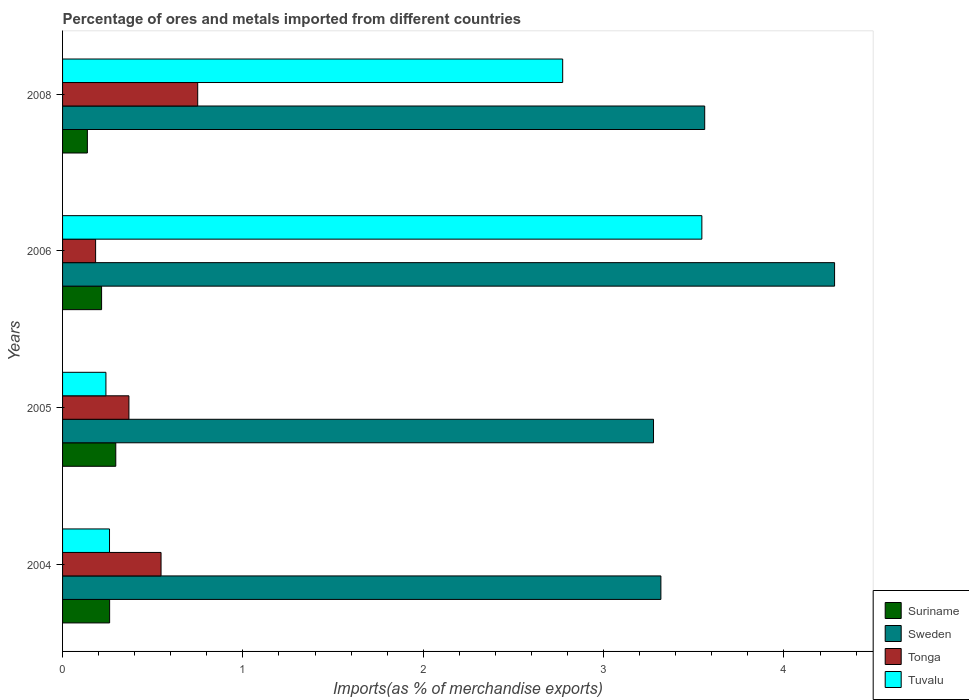How many different coloured bars are there?
Your response must be concise. 4. How many groups of bars are there?
Your response must be concise. 4. How many bars are there on the 3rd tick from the top?
Your response must be concise. 4. What is the percentage of imports to different countries in Suriname in 2008?
Your answer should be very brief. 0.14. Across all years, what is the maximum percentage of imports to different countries in Tonga?
Provide a succinct answer. 0.75. Across all years, what is the minimum percentage of imports to different countries in Tuvalu?
Ensure brevity in your answer.  0.24. In which year was the percentage of imports to different countries in Sweden minimum?
Your answer should be compact. 2005. What is the total percentage of imports to different countries in Sweden in the graph?
Keep it short and to the point. 14.44. What is the difference between the percentage of imports to different countries in Sweden in 2004 and that in 2006?
Make the answer very short. -0.96. What is the difference between the percentage of imports to different countries in Tuvalu in 2006 and the percentage of imports to different countries in Sweden in 2005?
Your answer should be very brief. 0.27. What is the average percentage of imports to different countries in Sweden per year?
Your answer should be compact. 3.61. In the year 2006, what is the difference between the percentage of imports to different countries in Tonga and percentage of imports to different countries in Suriname?
Keep it short and to the point. -0.03. What is the ratio of the percentage of imports to different countries in Tuvalu in 2004 to that in 2006?
Your answer should be compact. 0.07. Is the percentage of imports to different countries in Tonga in 2006 less than that in 2008?
Your answer should be compact. Yes. What is the difference between the highest and the second highest percentage of imports to different countries in Tonga?
Your answer should be compact. 0.2. What is the difference between the highest and the lowest percentage of imports to different countries in Sweden?
Your response must be concise. 1. Is it the case that in every year, the sum of the percentage of imports to different countries in Suriname and percentage of imports to different countries in Sweden is greater than the sum of percentage of imports to different countries in Tuvalu and percentage of imports to different countries in Tonga?
Your answer should be very brief. Yes. What does the 2nd bar from the top in 2006 represents?
Your answer should be compact. Tonga. What does the 3rd bar from the bottom in 2006 represents?
Your answer should be very brief. Tonga. How many bars are there?
Provide a succinct answer. 16. Are all the bars in the graph horizontal?
Offer a very short reply. Yes. How many years are there in the graph?
Your response must be concise. 4. What is the difference between two consecutive major ticks on the X-axis?
Keep it short and to the point. 1. Are the values on the major ticks of X-axis written in scientific E-notation?
Provide a succinct answer. No. Does the graph contain grids?
Offer a terse response. No. Where does the legend appear in the graph?
Offer a terse response. Bottom right. How are the legend labels stacked?
Offer a terse response. Vertical. What is the title of the graph?
Keep it short and to the point. Percentage of ores and metals imported from different countries. Does "Papua New Guinea" appear as one of the legend labels in the graph?
Ensure brevity in your answer.  No. What is the label or title of the X-axis?
Your response must be concise. Imports(as % of merchandise exports). What is the Imports(as % of merchandise exports) of Suriname in 2004?
Your response must be concise. 0.26. What is the Imports(as % of merchandise exports) of Sweden in 2004?
Give a very brief answer. 3.32. What is the Imports(as % of merchandise exports) in Tonga in 2004?
Ensure brevity in your answer.  0.55. What is the Imports(as % of merchandise exports) in Tuvalu in 2004?
Provide a short and direct response. 0.26. What is the Imports(as % of merchandise exports) of Suriname in 2005?
Keep it short and to the point. 0.3. What is the Imports(as % of merchandise exports) of Sweden in 2005?
Your answer should be compact. 3.28. What is the Imports(as % of merchandise exports) in Tonga in 2005?
Provide a succinct answer. 0.37. What is the Imports(as % of merchandise exports) of Tuvalu in 2005?
Keep it short and to the point. 0.24. What is the Imports(as % of merchandise exports) of Suriname in 2006?
Give a very brief answer. 0.22. What is the Imports(as % of merchandise exports) in Sweden in 2006?
Offer a very short reply. 4.28. What is the Imports(as % of merchandise exports) in Tonga in 2006?
Keep it short and to the point. 0.18. What is the Imports(as % of merchandise exports) in Tuvalu in 2006?
Make the answer very short. 3.54. What is the Imports(as % of merchandise exports) in Suriname in 2008?
Make the answer very short. 0.14. What is the Imports(as % of merchandise exports) in Sweden in 2008?
Offer a terse response. 3.56. What is the Imports(as % of merchandise exports) in Tonga in 2008?
Make the answer very short. 0.75. What is the Imports(as % of merchandise exports) in Tuvalu in 2008?
Provide a succinct answer. 2.77. Across all years, what is the maximum Imports(as % of merchandise exports) in Suriname?
Provide a short and direct response. 0.3. Across all years, what is the maximum Imports(as % of merchandise exports) of Sweden?
Make the answer very short. 4.28. Across all years, what is the maximum Imports(as % of merchandise exports) in Tonga?
Offer a terse response. 0.75. Across all years, what is the maximum Imports(as % of merchandise exports) of Tuvalu?
Offer a terse response. 3.54. Across all years, what is the minimum Imports(as % of merchandise exports) in Suriname?
Your answer should be very brief. 0.14. Across all years, what is the minimum Imports(as % of merchandise exports) of Sweden?
Give a very brief answer. 3.28. Across all years, what is the minimum Imports(as % of merchandise exports) in Tonga?
Give a very brief answer. 0.18. Across all years, what is the minimum Imports(as % of merchandise exports) in Tuvalu?
Make the answer very short. 0.24. What is the total Imports(as % of merchandise exports) in Suriname in the graph?
Keep it short and to the point. 0.91. What is the total Imports(as % of merchandise exports) in Sweden in the graph?
Give a very brief answer. 14.44. What is the total Imports(as % of merchandise exports) in Tonga in the graph?
Ensure brevity in your answer.  1.85. What is the total Imports(as % of merchandise exports) of Tuvalu in the graph?
Offer a very short reply. 6.82. What is the difference between the Imports(as % of merchandise exports) in Suriname in 2004 and that in 2005?
Keep it short and to the point. -0.03. What is the difference between the Imports(as % of merchandise exports) in Sweden in 2004 and that in 2005?
Provide a succinct answer. 0.04. What is the difference between the Imports(as % of merchandise exports) in Tonga in 2004 and that in 2005?
Provide a succinct answer. 0.18. What is the difference between the Imports(as % of merchandise exports) of Tuvalu in 2004 and that in 2005?
Ensure brevity in your answer.  0.02. What is the difference between the Imports(as % of merchandise exports) in Suriname in 2004 and that in 2006?
Provide a succinct answer. 0.04. What is the difference between the Imports(as % of merchandise exports) in Sweden in 2004 and that in 2006?
Your answer should be compact. -0.96. What is the difference between the Imports(as % of merchandise exports) in Tonga in 2004 and that in 2006?
Provide a succinct answer. 0.36. What is the difference between the Imports(as % of merchandise exports) in Tuvalu in 2004 and that in 2006?
Your answer should be compact. -3.28. What is the difference between the Imports(as % of merchandise exports) in Suriname in 2004 and that in 2008?
Keep it short and to the point. 0.12. What is the difference between the Imports(as % of merchandise exports) in Sweden in 2004 and that in 2008?
Give a very brief answer. -0.24. What is the difference between the Imports(as % of merchandise exports) in Tonga in 2004 and that in 2008?
Give a very brief answer. -0.2. What is the difference between the Imports(as % of merchandise exports) of Tuvalu in 2004 and that in 2008?
Your answer should be compact. -2.51. What is the difference between the Imports(as % of merchandise exports) in Suriname in 2005 and that in 2006?
Provide a succinct answer. 0.08. What is the difference between the Imports(as % of merchandise exports) in Sweden in 2005 and that in 2006?
Provide a succinct answer. -1. What is the difference between the Imports(as % of merchandise exports) of Tonga in 2005 and that in 2006?
Offer a terse response. 0.18. What is the difference between the Imports(as % of merchandise exports) in Tuvalu in 2005 and that in 2006?
Offer a terse response. -3.3. What is the difference between the Imports(as % of merchandise exports) of Suriname in 2005 and that in 2008?
Provide a succinct answer. 0.16. What is the difference between the Imports(as % of merchandise exports) in Sweden in 2005 and that in 2008?
Give a very brief answer. -0.28. What is the difference between the Imports(as % of merchandise exports) in Tonga in 2005 and that in 2008?
Ensure brevity in your answer.  -0.38. What is the difference between the Imports(as % of merchandise exports) in Tuvalu in 2005 and that in 2008?
Ensure brevity in your answer.  -2.53. What is the difference between the Imports(as % of merchandise exports) of Suriname in 2006 and that in 2008?
Your answer should be compact. 0.08. What is the difference between the Imports(as % of merchandise exports) of Sweden in 2006 and that in 2008?
Provide a short and direct response. 0.72. What is the difference between the Imports(as % of merchandise exports) in Tonga in 2006 and that in 2008?
Your answer should be compact. -0.57. What is the difference between the Imports(as % of merchandise exports) in Tuvalu in 2006 and that in 2008?
Offer a very short reply. 0.77. What is the difference between the Imports(as % of merchandise exports) in Suriname in 2004 and the Imports(as % of merchandise exports) in Sweden in 2005?
Provide a short and direct response. -3.02. What is the difference between the Imports(as % of merchandise exports) in Suriname in 2004 and the Imports(as % of merchandise exports) in Tonga in 2005?
Ensure brevity in your answer.  -0.11. What is the difference between the Imports(as % of merchandise exports) in Suriname in 2004 and the Imports(as % of merchandise exports) in Tuvalu in 2005?
Your response must be concise. 0.02. What is the difference between the Imports(as % of merchandise exports) of Sweden in 2004 and the Imports(as % of merchandise exports) of Tonga in 2005?
Offer a very short reply. 2.95. What is the difference between the Imports(as % of merchandise exports) in Sweden in 2004 and the Imports(as % of merchandise exports) in Tuvalu in 2005?
Your answer should be compact. 3.08. What is the difference between the Imports(as % of merchandise exports) in Tonga in 2004 and the Imports(as % of merchandise exports) in Tuvalu in 2005?
Offer a terse response. 0.31. What is the difference between the Imports(as % of merchandise exports) in Suriname in 2004 and the Imports(as % of merchandise exports) in Sweden in 2006?
Ensure brevity in your answer.  -4.02. What is the difference between the Imports(as % of merchandise exports) of Suriname in 2004 and the Imports(as % of merchandise exports) of Tonga in 2006?
Provide a short and direct response. 0.08. What is the difference between the Imports(as % of merchandise exports) of Suriname in 2004 and the Imports(as % of merchandise exports) of Tuvalu in 2006?
Your answer should be very brief. -3.28. What is the difference between the Imports(as % of merchandise exports) in Sweden in 2004 and the Imports(as % of merchandise exports) in Tonga in 2006?
Ensure brevity in your answer.  3.13. What is the difference between the Imports(as % of merchandise exports) in Sweden in 2004 and the Imports(as % of merchandise exports) in Tuvalu in 2006?
Your answer should be very brief. -0.23. What is the difference between the Imports(as % of merchandise exports) in Tonga in 2004 and the Imports(as % of merchandise exports) in Tuvalu in 2006?
Your answer should be compact. -3. What is the difference between the Imports(as % of merchandise exports) of Suriname in 2004 and the Imports(as % of merchandise exports) of Sweden in 2008?
Make the answer very short. -3.3. What is the difference between the Imports(as % of merchandise exports) of Suriname in 2004 and the Imports(as % of merchandise exports) of Tonga in 2008?
Your answer should be very brief. -0.49. What is the difference between the Imports(as % of merchandise exports) of Suriname in 2004 and the Imports(as % of merchandise exports) of Tuvalu in 2008?
Ensure brevity in your answer.  -2.51. What is the difference between the Imports(as % of merchandise exports) of Sweden in 2004 and the Imports(as % of merchandise exports) of Tonga in 2008?
Keep it short and to the point. 2.57. What is the difference between the Imports(as % of merchandise exports) of Sweden in 2004 and the Imports(as % of merchandise exports) of Tuvalu in 2008?
Offer a very short reply. 0.54. What is the difference between the Imports(as % of merchandise exports) of Tonga in 2004 and the Imports(as % of merchandise exports) of Tuvalu in 2008?
Your answer should be very brief. -2.23. What is the difference between the Imports(as % of merchandise exports) in Suriname in 2005 and the Imports(as % of merchandise exports) in Sweden in 2006?
Provide a short and direct response. -3.99. What is the difference between the Imports(as % of merchandise exports) in Suriname in 2005 and the Imports(as % of merchandise exports) in Tonga in 2006?
Your answer should be compact. 0.11. What is the difference between the Imports(as % of merchandise exports) of Suriname in 2005 and the Imports(as % of merchandise exports) of Tuvalu in 2006?
Provide a short and direct response. -3.25. What is the difference between the Imports(as % of merchandise exports) of Sweden in 2005 and the Imports(as % of merchandise exports) of Tonga in 2006?
Your response must be concise. 3.09. What is the difference between the Imports(as % of merchandise exports) in Sweden in 2005 and the Imports(as % of merchandise exports) in Tuvalu in 2006?
Make the answer very short. -0.27. What is the difference between the Imports(as % of merchandise exports) in Tonga in 2005 and the Imports(as % of merchandise exports) in Tuvalu in 2006?
Provide a succinct answer. -3.18. What is the difference between the Imports(as % of merchandise exports) of Suriname in 2005 and the Imports(as % of merchandise exports) of Sweden in 2008?
Your answer should be very brief. -3.27. What is the difference between the Imports(as % of merchandise exports) in Suriname in 2005 and the Imports(as % of merchandise exports) in Tonga in 2008?
Your answer should be compact. -0.45. What is the difference between the Imports(as % of merchandise exports) of Suriname in 2005 and the Imports(as % of merchandise exports) of Tuvalu in 2008?
Your answer should be compact. -2.48. What is the difference between the Imports(as % of merchandise exports) in Sweden in 2005 and the Imports(as % of merchandise exports) in Tonga in 2008?
Make the answer very short. 2.53. What is the difference between the Imports(as % of merchandise exports) in Sweden in 2005 and the Imports(as % of merchandise exports) in Tuvalu in 2008?
Give a very brief answer. 0.5. What is the difference between the Imports(as % of merchandise exports) in Tonga in 2005 and the Imports(as % of merchandise exports) in Tuvalu in 2008?
Offer a terse response. -2.41. What is the difference between the Imports(as % of merchandise exports) in Suriname in 2006 and the Imports(as % of merchandise exports) in Sweden in 2008?
Ensure brevity in your answer.  -3.34. What is the difference between the Imports(as % of merchandise exports) of Suriname in 2006 and the Imports(as % of merchandise exports) of Tonga in 2008?
Give a very brief answer. -0.53. What is the difference between the Imports(as % of merchandise exports) in Suriname in 2006 and the Imports(as % of merchandise exports) in Tuvalu in 2008?
Your response must be concise. -2.56. What is the difference between the Imports(as % of merchandise exports) of Sweden in 2006 and the Imports(as % of merchandise exports) of Tonga in 2008?
Provide a succinct answer. 3.53. What is the difference between the Imports(as % of merchandise exports) in Sweden in 2006 and the Imports(as % of merchandise exports) in Tuvalu in 2008?
Your response must be concise. 1.51. What is the difference between the Imports(as % of merchandise exports) in Tonga in 2006 and the Imports(as % of merchandise exports) in Tuvalu in 2008?
Your answer should be very brief. -2.59. What is the average Imports(as % of merchandise exports) in Suriname per year?
Provide a succinct answer. 0.23. What is the average Imports(as % of merchandise exports) in Sweden per year?
Your response must be concise. 3.61. What is the average Imports(as % of merchandise exports) of Tonga per year?
Your answer should be very brief. 0.46. What is the average Imports(as % of merchandise exports) of Tuvalu per year?
Your answer should be compact. 1.7. In the year 2004, what is the difference between the Imports(as % of merchandise exports) of Suriname and Imports(as % of merchandise exports) of Sweden?
Your response must be concise. -3.06. In the year 2004, what is the difference between the Imports(as % of merchandise exports) of Suriname and Imports(as % of merchandise exports) of Tonga?
Your response must be concise. -0.29. In the year 2004, what is the difference between the Imports(as % of merchandise exports) in Suriname and Imports(as % of merchandise exports) in Tuvalu?
Provide a short and direct response. 0. In the year 2004, what is the difference between the Imports(as % of merchandise exports) in Sweden and Imports(as % of merchandise exports) in Tonga?
Offer a very short reply. 2.77. In the year 2004, what is the difference between the Imports(as % of merchandise exports) of Sweden and Imports(as % of merchandise exports) of Tuvalu?
Provide a short and direct response. 3.06. In the year 2004, what is the difference between the Imports(as % of merchandise exports) in Tonga and Imports(as % of merchandise exports) in Tuvalu?
Ensure brevity in your answer.  0.29. In the year 2005, what is the difference between the Imports(as % of merchandise exports) of Suriname and Imports(as % of merchandise exports) of Sweden?
Provide a short and direct response. -2.98. In the year 2005, what is the difference between the Imports(as % of merchandise exports) in Suriname and Imports(as % of merchandise exports) in Tonga?
Ensure brevity in your answer.  -0.07. In the year 2005, what is the difference between the Imports(as % of merchandise exports) in Suriname and Imports(as % of merchandise exports) in Tuvalu?
Give a very brief answer. 0.05. In the year 2005, what is the difference between the Imports(as % of merchandise exports) in Sweden and Imports(as % of merchandise exports) in Tonga?
Offer a terse response. 2.91. In the year 2005, what is the difference between the Imports(as % of merchandise exports) of Sweden and Imports(as % of merchandise exports) of Tuvalu?
Your response must be concise. 3.04. In the year 2005, what is the difference between the Imports(as % of merchandise exports) of Tonga and Imports(as % of merchandise exports) of Tuvalu?
Offer a terse response. 0.13. In the year 2006, what is the difference between the Imports(as % of merchandise exports) in Suriname and Imports(as % of merchandise exports) in Sweden?
Provide a short and direct response. -4.06. In the year 2006, what is the difference between the Imports(as % of merchandise exports) in Suriname and Imports(as % of merchandise exports) in Tonga?
Ensure brevity in your answer.  0.03. In the year 2006, what is the difference between the Imports(as % of merchandise exports) of Suriname and Imports(as % of merchandise exports) of Tuvalu?
Provide a succinct answer. -3.33. In the year 2006, what is the difference between the Imports(as % of merchandise exports) of Sweden and Imports(as % of merchandise exports) of Tonga?
Give a very brief answer. 4.1. In the year 2006, what is the difference between the Imports(as % of merchandise exports) in Sweden and Imports(as % of merchandise exports) in Tuvalu?
Provide a short and direct response. 0.74. In the year 2006, what is the difference between the Imports(as % of merchandise exports) in Tonga and Imports(as % of merchandise exports) in Tuvalu?
Offer a very short reply. -3.36. In the year 2008, what is the difference between the Imports(as % of merchandise exports) of Suriname and Imports(as % of merchandise exports) of Sweden?
Ensure brevity in your answer.  -3.42. In the year 2008, what is the difference between the Imports(as % of merchandise exports) in Suriname and Imports(as % of merchandise exports) in Tonga?
Offer a very short reply. -0.61. In the year 2008, what is the difference between the Imports(as % of merchandise exports) of Suriname and Imports(as % of merchandise exports) of Tuvalu?
Keep it short and to the point. -2.64. In the year 2008, what is the difference between the Imports(as % of merchandise exports) of Sweden and Imports(as % of merchandise exports) of Tonga?
Your answer should be compact. 2.81. In the year 2008, what is the difference between the Imports(as % of merchandise exports) in Sweden and Imports(as % of merchandise exports) in Tuvalu?
Your answer should be compact. 0.79. In the year 2008, what is the difference between the Imports(as % of merchandise exports) of Tonga and Imports(as % of merchandise exports) of Tuvalu?
Make the answer very short. -2.02. What is the ratio of the Imports(as % of merchandise exports) in Suriname in 2004 to that in 2005?
Offer a terse response. 0.88. What is the ratio of the Imports(as % of merchandise exports) in Sweden in 2004 to that in 2005?
Offer a terse response. 1.01. What is the ratio of the Imports(as % of merchandise exports) of Tonga in 2004 to that in 2005?
Provide a short and direct response. 1.48. What is the ratio of the Imports(as % of merchandise exports) of Tuvalu in 2004 to that in 2005?
Your response must be concise. 1.08. What is the ratio of the Imports(as % of merchandise exports) in Suriname in 2004 to that in 2006?
Your answer should be very brief. 1.21. What is the ratio of the Imports(as % of merchandise exports) of Sweden in 2004 to that in 2006?
Make the answer very short. 0.78. What is the ratio of the Imports(as % of merchandise exports) of Tonga in 2004 to that in 2006?
Offer a terse response. 2.98. What is the ratio of the Imports(as % of merchandise exports) in Tuvalu in 2004 to that in 2006?
Make the answer very short. 0.07. What is the ratio of the Imports(as % of merchandise exports) of Suriname in 2004 to that in 2008?
Ensure brevity in your answer.  1.9. What is the ratio of the Imports(as % of merchandise exports) of Sweden in 2004 to that in 2008?
Keep it short and to the point. 0.93. What is the ratio of the Imports(as % of merchandise exports) in Tonga in 2004 to that in 2008?
Provide a succinct answer. 0.73. What is the ratio of the Imports(as % of merchandise exports) of Tuvalu in 2004 to that in 2008?
Give a very brief answer. 0.09. What is the ratio of the Imports(as % of merchandise exports) of Suriname in 2005 to that in 2006?
Provide a succinct answer. 1.36. What is the ratio of the Imports(as % of merchandise exports) in Sweden in 2005 to that in 2006?
Ensure brevity in your answer.  0.77. What is the ratio of the Imports(as % of merchandise exports) of Tonga in 2005 to that in 2006?
Ensure brevity in your answer.  2.01. What is the ratio of the Imports(as % of merchandise exports) in Tuvalu in 2005 to that in 2006?
Give a very brief answer. 0.07. What is the ratio of the Imports(as % of merchandise exports) in Suriname in 2005 to that in 2008?
Offer a very short reply. 2.15. What is the ratio of the Imports(as % of merchandise exports) of Sweden in 2005 to that in 2008?
Ensure brevity in your answer.  0.92. What is the ratio of the Imports(as % of merchandise exports) in Tonga in 2005 to that in 2008?
Ensure brevity in your answer.  0.49. What is the ratio of the Imports(as % of merchandise exports) in Tuvalu in 2005 to that in 2008?
Your response must be concise. 0.09. What is the ratio of the Imports(as % of merchandise exports) in Suriname in 2006 to that in 2008?
Your answer should be compact. 1.57. What is the ratio of the Imports(as % of merchandise exports) in Sweden in 2006 to that in 2008?
Your answer should be very brief. 1.2. What is the ratio of the Imports(as % of merchandise exports) in Tonga in 2006 to that in 2008?
Your response must be concise. 0.24. What is the ratio of the Imports(as % of merchandise exports) of Tuvalu in 2006 to that in 2008?
Your answer should be very brief. 1.28. What is the difference between the highest and the second highest Imports(as % of merchandise exports) in Suriname?
Offer a very short reply. 0.03. What is the difference between the highest and the second highest Imports(as % of merchandise exports) of Sweden?
Give a very brief answer. 0.72. What is the difference between the highest and the second highest Imports(as % of merchandise exports) in Tonga?
Your answer should be very brief. 0.2. What is the difference between the highest and the second highest Imports(as % of merchandise exports) of Tuvalu?
Make the answer very short. 0.77. What is the difference between the highest and the lowest Imports(as % of merchandise exports) of Suriname?
Ensure brevity in your answer.  0.16. What is the difference between the highest and the lowest Imports(as % of merchandise exports) in Sweden?
Offer a very short reply. 1. What is the difference between the highest and the lowest Imports(as % of merchandise exports) of Tonga?
Make the answer very short. 0.57. What is the difference between the highest and the lowest Imports(as % of merchandise exports) of Tuvalu?
Give a very brief answer. 3.3. 